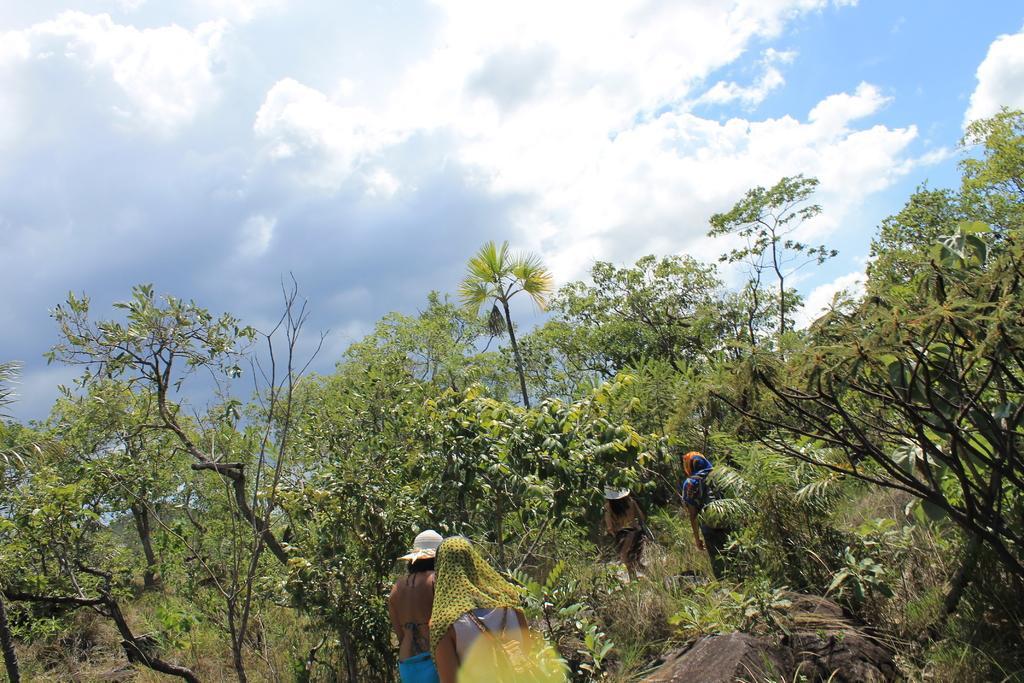Describe this image in one or two sentences. In the picture I can see four tribal people walking on the ground. I can see the trees. There are clouds in the sky. 